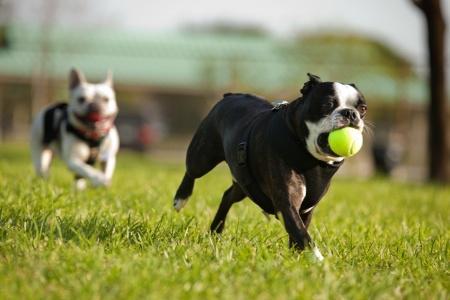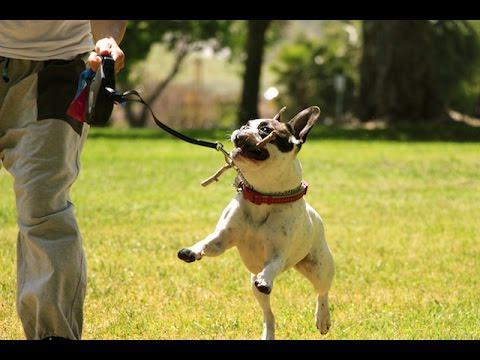The first image is the image on the left, the second image is the image on the right. For the images displayed, is the sentence "The left image includes a dog playing with a tennis ball." factually correct? Answer yes or no. Yes. The first image is the image on the left, the second image is the image on the right. For the images shown, is this caption "An image shows a tennis ball in front of one french bulldog, but not in contact with it." true? Answer yes or no. No. 